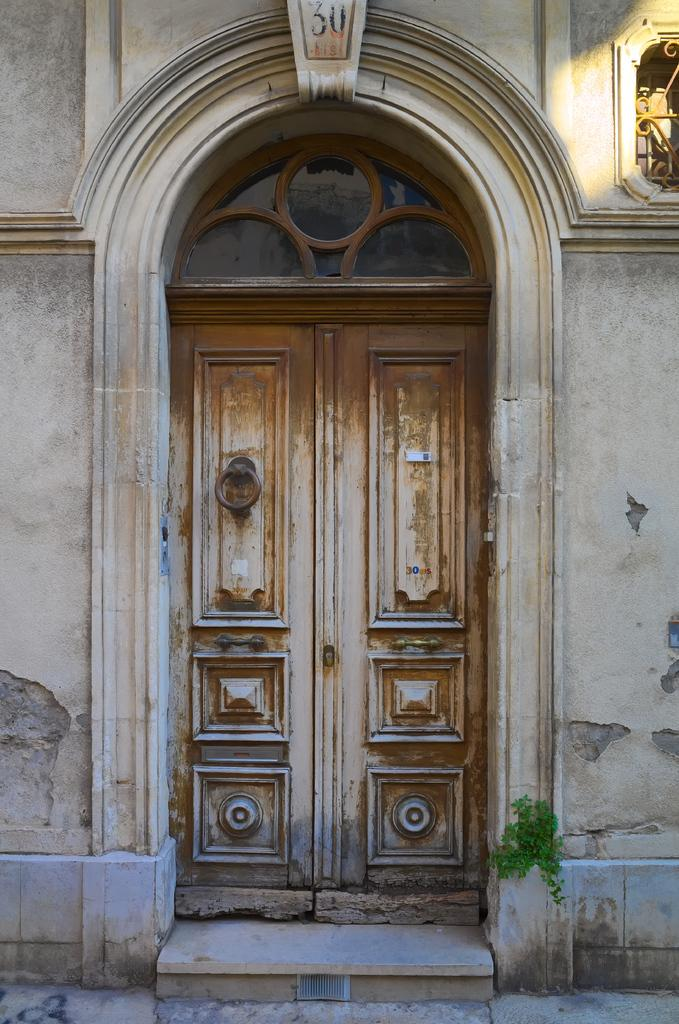What is one of the main features of the image? There is a door in the image. What type of outdoor environment can be seen in the image? There is green grass visible in the image. Where is the ventilation located in the image? The ventilation is in the top right corner of the image. What number is present at the top of the image? The number "30" is present at the top of the image. How does the turkey contribute to the ventilation in the image? There is no turkey present in the image, so it cannot contribute to the ventilation. 